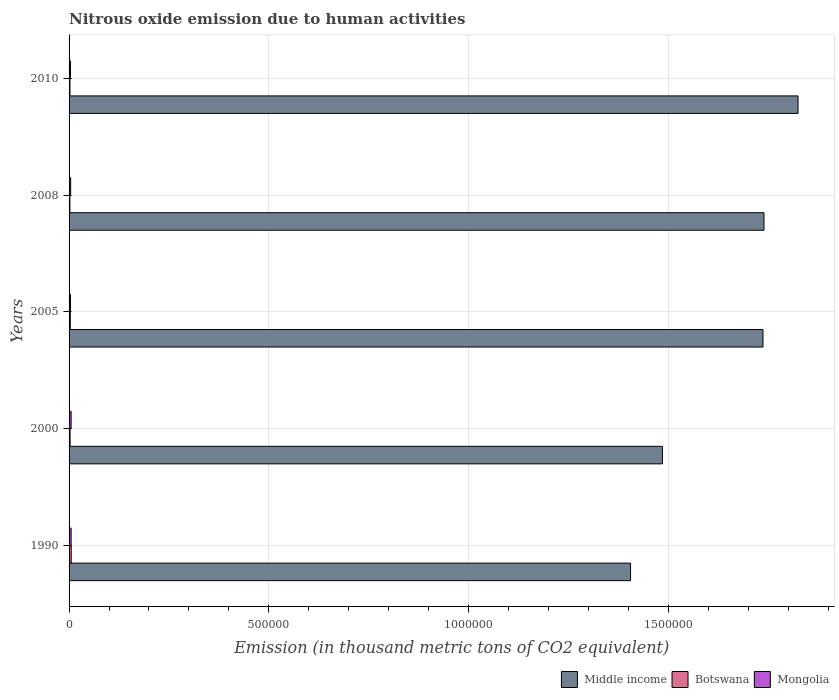How many groups of bars are there?
Your answer should be very brief. 5. Are the number of bars on each tick of the Y-axis equal?
Keep it short and to the point. Yes. In how many cases, is the number of bars for a given year not equal to the number of legend labels?
Ensure brevity in your answer.  0. What is the amount of nitrous oxide emitted in Middle income in 2010?
Your answer should be very brief. 1.82e+06. Across all years, what is the maximum amount of nitrous oxide emitted in Mongolia?
Provide a short and direct response. 5151. Across all years, what is the minimum amount of nitrous oxide emitted in Middle income?
Offer a terse response. 1.41e+06. In which year was the amount of nitrous oxide emitted in Middle income maximum?
Provide a succinct answer. 2010. In which year was the amount of nitrous oxide emitted in Mongolia minimum?
Keep it short and to the point. 2010. What is the total amount of nitrous oxide emitted in Botswana in the graph?
Keep it short and to the point. 1.52e+04. What is the difference between the amount of nitrous oxide emitted in Mongolia in 2000 and that in 2008?
Provide a short and direct response. 1153. What is the difference between the amount of nitrous oxide emitted in Botswana in 2010 and the amount of nitrous oxide emitted in Mongolia in 2005?
Your answer should be very brief. -1350.6. What is the average amount of nitrous oxide emitted in Middle income per year?
Offer a terse response. 1.64e+06. In the year 2000, what is the difference between the amount of nitrous oxide emitted in Middle income and amount of nitrous oxide emitted in Botswana?
Your answer should be compact. 1.48e+06. What is the ratio of the amount of nitrous oxide emitted in Mongolia in 2005 to that in 2010?
Ensure brevity in your answer.  1.02. Is the difference between the amount of nitrous oxide emitted in Middle income in 2008 and 2010 greater than the difference between the amount of nitrous oxide emitted in Botswana in 2008 and 2010?
Keep it short and to the point. No. What is the difference between the highest and the second highest amount of nitrous oxide emitted in Middle income?
Your answer should be very brief. 8.53e+04. What is the difference between the highest and the lowest amount of nitrous oxide emitted in Middle income?
Provide a short and direct response. 4.19e+05. Is the sum of the amount of nitrous oxide emitted in Middle income in 2005 and 2010 greater than the maximum amount of nitrous oxide emitted in Mongolia across all years?
Your answer should be compact. Yes. What does the 2nd bar from the top in 2005 represents?
Give a very brief answer. Botswana. What does the 3rd bar from the bottom in 2008 represents?
Provide a succinct answer. Mongolia. How many years are there in the graph?
Provide a short and direct response. 5. What is the difference between two consecutive major ticks on the X-axis?
Give a very brief answer. 5.00e+05. Does the graph contain any zero values?
Your response must be concise. No. Does the graph contain grids?
Provide a short and direct response. Yes. What is the title of the graph?
Ensure brevity in your answer.  Nitrous oxide emission due to human activities. Does "Gabon" appear as one of the legend labels in the graph?
Provide a short and direct response. No. What is the label or title of the X-axis?
Keep it short and to the point. Emission (in thousand metric tons of CO2 equivalent). What is the label or title of the Y-axis?
Offer a terse response. Years. What is the Emission (in thousand metric tons of CO2 equivalent) in Middle income in 1990?
Make the answer very short. 1.41e+06. What is the Emission (in thousand metric tons of CO2 equivalent) of Botswana in 1990?
Keep it short and to the point. 5394.5. What is the Emission (in thousand metric tons of CO2 equivalent) in Mongolia in 1990?
Make the answer very short. 5151. What is the Emission (in thousand metric tons of CO2 equivalent) of Middle income in 2000?
Provide a short and direct response. 1.49e+06. What is the Emission (in thousand metric tons of CO2 equivalent) of Botswana in 2000?
Offer a very short reply. 2523.6. What is the Emission (in thousand metric tons of CO2 equivalent) of Mongolia in 2000?
Ensure brevity in your answer.  5106.8. What is the Emission (in thousand metric tons of CO2 equivalent) of Middle income in 2005?
Your response must be concise. 1.74e+06. What is the Emission (in thousand metric tons of CO2 equivalent) in Botswana in 2005?
Keep it short and to the point. 3096.5. What is the Emission (in thousand metric tons of CO2 equivalent) in Mongolia in 2005?
Keep it short and to the point. 3535.4. What is the Emission (in thousand metric tons of CO2 equivalent) in Middle income in 2008?
Keep it short and to the point. 1.74e+06. What is the Emission (in thousand metric tons of CO2 equivalent) of Botswana in 2008?
Keep it short and to the point. 1998.1. What is the Emission (in thousand metric tons of CO2 equivalent) in Mongolia in 2008?
Provide a short and direct response. 3953.8. What is the Emission (in thousand metric tons of CO2 equivalent) of Middle income in 2010?
Keep it short and to the point. 1.82e+06. What is the Emission (in thousand metric tons of CO2 equivalent) of Botswana in 2010?
Make the answer very short. 2184.8. What is the Emission (in thousand metric tons of CO2 equivalent) in Mongolia in 2010?
Provide a succinct answer. 3478.2. Across all years, what is the maximum Emission (in thousand metric tons of CO2 equivalent) of Middle income?
Provide a short and direct response. 1.82e+06. Across all years, what is the maximum Emission (in thousand metric tons of CO2 equivalent) of Botswana?
Provide a short and direct response. 5394.5. Across all years, what is the maximum Emission (in thousand metric tons of CO2 equivalent) in Mongolia?
Your answer should be very brief. 5151. Across all years, what is the minimum Emission (in thousand metric tons of CO2 equivalent) of Middle income?
Your response must be concise. 1.41e+06. Across all years, what is the minimum Emission (in thousand metric tons of CO2 equivalent) in Botswana?
Make the answer very short. 1998.1. Across all years, what is the minimum Emission (in thousand metric tons of CO2 equivalent) of Mongolia?
Your answer should be compact. 3478.2. What is the total Emission (in thousand metric tons of CO2 equivalent) of Middle income in the graph?
Offer a terse response. 8.19e+06. What is the total Emission (in thousand metric tons of CO2 equivalent) of Botswana in the graph?
Your answer should be very brief. 1.52e+04. What is the total Emission (in thousand metric tons of CO2 equivalent) in Mongolia in the graph?
Provide a short and direct response. 2.12e+04. What is the difference between the Emission (in thousand metric tons of CO2 equivalent) in Middle income in 1990 and that in 2000?
Ensure brevity in your answer.  -7.98e+04. What is the difference between the Emission (in thousand metric tons of CO2 equivalent) of Botswana in 1990 and that in 2000?
Your answer should be compact. 2870.9. What is the difference between the Emission (in thousand metric tons of CO2 equivalent) in Mongolia in 1990 and that in 2000?
Give a very brief answer. 44.2. What is the difference between the Emission (in thousand metric tons of CO2 equivalent) in Middle income in 1990 and that in 2005?
Your response must be concise. -3.31e+05. What is the difference between the Emission (in thousand metric tons of CO2 equivalent) in Botswana in 1990 and that in 2005?
Your response must be concise. 2298. What is the difference between the Emission (in thousand metric tons of CO2 equivalent) in Mongolia in 1990 and that in 2005?
Offer a terse response. 1615.6. What is the difference between the Emission (in thousand metric tons of CO2 equivalent) of Middle income in 1990 and that in 2008?
Give a very brief answer. -3.34e+05. What is the difference between the Emission (in thousand metric tons of CO2 equivalent) in Botswana in 1990 and that in 2008?
Offer a terse response. 3396.4. What is the difference between the Emission (in thousand metric tons of CO2 equivalent) in Mongolia in 1990 and that in 2008?
Offer a very short reply. 1197.2. What is the difference between the Emission (in thousand metric tons of CO2 equivalent) of Middle income in 1990 and that in 2010?
Give a very brief answer. -4.19e+05. What is the difference between the Emission (in thousand metric tons of CO2 equivalent) of Botswana in 1990 and that in 2010?
Give a very brief answer. 3209.7. What is the difference between the Emission (in thousand metric tons of CO2 equivalent) in Mongolia in 1990 and that in 2010?
Make the answer very short. 1672.8. What is the difference between the Emission (in thousand metric tons of CO2 equivalent) of Middle income in 2000 and that in 2005?
Keep it short and to the point. -2.52e+05. What is the difference between the Emission (in thousand metric tons of CO2 equivalent) in Botswana in 2000 and that in 2005?
Your answer should be very brief. -572.9. What is the difference between the Emission (in thousand metric tons of CO2 equivalent) of Mongolia in 2000 and that in 2005?
Ensure brevity in your answer.  1571.4. What is the difference between the Emission (in thousand metric tons of CO2 equivalent) in Middle income in 2000 and that in 2008?
Your answer should be very brief. -2.54e+05. What is the difference between the Emission (in thousand metric tons of CO2 equivalent) of Botswana in 2000 and that in 2008?
Provide a short and direct response. 525.5. What is the difference between the Emission (in thousand metric tons of CO2 equivalent) in Mongolia in 2000 and that in 2008?
Make the answer very short. 1153. What is the difference between the Emission (in thousand metric tons of CO2 equivalent) in Middle income in 2000 and that in 2010?
Your answer should be very brief. -3.39e+05. What is the difference between the Emission (in thousand metric tons of CO2 equivalent) of Botswana in 2000 and that in 2010?
Keep it short and to the point. 338.8. What is the difference between the Emission (in thousand metric tons of CO2 equivalent) of Mongolia in 2000 and that in 2010?
Your answer should be compact. 1628.6. What is the difference between the Emission (in thousand metric tons of CO2 equivalent) in Middle income in 2005 and that in 2008?
Provide a succinct answer. -2525.2. What is the difference between the Emission (in thousand metric tons of CO2 equivalent) of Botswana in 2005 and that in 2008?
Give a very brief answer. 1098.4. What is the difference between the Emission (in thousand metric tons of CO2 equivalent) of Mongolia in 2005 and that in 2008?
Offer a very short reply. -418.4. What is the difference between the Emission (in thousand metric tons of CO2 equivalent) of Middle income in 2005 and that in 2010?
Ensure brevity in your answer.  -8.78e+04. What is the difference between the Emission (in thousand metric tons of CO2 equivalent) of Botswana in 2005 and that in 2010?
Give a very brief answer. 911.7. What is the difference between the Emission (in thousand metric tons of CO2 equivalent) in Mongolia in 2005 and that in 2010?
Your answer should be compact. 57.2. What is the difference between the Emission (in thousand metric tons of CO2 equivalent) of Middle income in 2008 and that in 2010?
Your answer should be compact. -8.53e+04. What is the difference between the Emission (in thousand metric tons of CO2 equivalent) of Botswana in 2008 and that in 2010?
Offer a terse response. -186.7. What is the difference between the Emission (in thousand metric tons of CO2 equivalent) in Mongolia in 2008 and that in 2010?
Make the answer very short. 475.6. What is the difference between the Emission (in thousand metric tons of CO2 equivalent) of Middle income in 1990 and the Emission (in thousand metric tons of CO2 equivalent) of Botswana in 2000?
Offer a terse response. 1.40e+06. What is the difference between the Emission (in thousand metric tons of CO2 equivalent) of Middle income in 1990 and the Emission (in thousand metric tons of CO2 equivalent) of Mongolia in 2000?
Offer a terse response. 1.40e+06. What is the difference between the Emission (in thousand metric tons of CO2 equivalent) in Botswana in 1990 and the Emission (in thousand metric tons of CO2 equivalent) in Mongolia in 2000?
Your response must be concise. 287.7. What is the difference between the Emission (in thousand metric tons of CO2 equivalent) in Middle income in 1990 and the Emission (in thousand metric tons of CO2 equivalent) in Botswana in 2005?
Offer a terse response. 1.40e+06. What is the difference between the Emission (in thousand metric tons of CO2 equivalent) in Middle income in 1990 and the Emission (in thousand metric tons of CO2 equivalent) in Mongolia in 2005?
Offer a very short reply. 1.40e+06. What is the difference between the Emission (in thousand metric tons of CO2 equivalent) in Botswana in 1990 and the Emission (in thousand metric tons of CO2 equivalent) in Mongolia in 2005?
Offer a terse response. 1859.1. What is the difference between the Emission (in thousand metric tons of CO2 equivalent) in Middle income in 1990 and the Emission (in thousand metric tons of CO2 equivalent) in Botswana in 2008?
Your answer should be compact. 1.40e+06. What is the difference between the Emission (in thousand metric tons of CO2 equivalent) of Middle income in 1990 and the Emission (in thousand metric tons of CO2 equivalent) of Mongolia in 2008?
Ensure brevity in your answer.  1.40e+06. What is the difference between the Emission (in thousand metric tons of CO2 equivalent) of Botswana in 1990 and the Emission (in thousand metric tons of CO2 equivalent) of Mongolia in 2008?
Make the answer very short. 1440.7. What is the difference between the Emission (in thousand metric tons of CO2 equivalent) of Middle income in 1990 and the Emission (in thousand metric tons of CO2 equivalent) of Botswana in 2010?
Your answer should be very brief. 1.40e+06. What is the difference between the Emission (in thousand metric tons of CO2 equivalent) in Middle income in 1990 and the Emission (in thousand metric tons of CO2 equivalent) in Mongolia in 2010?
Your answer should be very brief. 1.40e+06. What is the difference between the Emission (in thousand metric tons of CO2 equivalent) of Botswana in 1990 and the Emission (in thousand metric tons of CO2 equivalent) of Mongolia in 2010?
Provide a succinct answer. 1916.3. What is the difference between the Emission (in thousand metric tons of CO2 equivalent) in Middle income in 2000 and the Emission (in thousand metric tons of CO2 equivalent) in Botswana in 2005?
Offer a very short reply. 1.48e+06. What is the difference between the Emission (in thousand metric tons of CO2 equivalent) in Middle income in 2000 and the Emission (in thousand metric tons of CO2 equivalent) in Mongolia in 2005?
Offer a terse response. 1.48e+06. What is the difference between the Emission (in thousand metric tons of CO2 equivalent) of Botswana in 2000 and the Emission (in thousand metric tons of CO2 equivalent) of Mongolia in 2005?
Your response must be concise. -1011.8. What is the difference between the Emission (in thousand metric tons of CO2 equivalent) of Middle income in 2000 and the Emission (in thousand metric tons of CO2 equivalent) of Botswana in 2008?
Provide a short and direct response. 1.48e+06. What is the difference between the Emission (in thousand metric tons of CO2 equivalent) of Middle income in 2000 and the Emission (in thousand metric tons of CO2 equivalent) of Mongolia in 2008?
Offer a very short reply. 1.48e+06. What is the difference between the Emission (in thousand metric tons of CO2 equivalent) of Botswana in 2000 and the Emission (in thousand metric tons of CO2 equivalent) of Mongolia in 2008?
Your response must be concise. -1430.2. What is the difference between the Emission (in thousand metric tons of CO2 equivalent) of Middle income in 2000 and the Emission (in thousand metric tons of CO2 equivalent) of Botswana in 2010?
Offer a terse response. 1.48e+06. What is the difference between the Emission (in thousand metric tons of CO2 equivalent) of Middle income in 2000 and the Emission (in thousand metric tons of CO2 equivalent) of Mongolia in 2010?
Offer a terse response. 1.48e+06. What is the difference between the Emission (in thousand metric tons of CO2 equivalent) in Botswana in 2000 and the Emission (in thousand metric tons of CO2 equivalent) in Mongolia in 2010?
Offer a terse response. -954.6. What is the difference between the Emission (in thousand metric tons of CO2 equivalent) in Middle income in 2005 and the Emission (in thousand metric tons of CO2 equivalent) in Botswana in 2008?
Provide a succinct answer. 1.73e+06. What is the difference between the Emission (in thousand metric tons of CO2 equivalent) of Middle income in 2005 and the Emission (in thousand metric tons of CO2 equivalent) of Mongolia in 2008?
Your answer should be very brief. 1.73e+06. What is the difference between the Emission (in thousand metric tons of CO2 equivalent) of Botswana in 2005 and the Emission (in thousand metric tons of CO2 equivalent) of Mongolia in 2008?
Provide a short and direct response. -857.3. What is the difference between the Emission (in thousand metric tons of CO2 equivalent) in Middle income in 2005 and the Emission (in thousand metric tons of CO2 equivalent) in Botswana in 2010?
Give a very brief answer. 1.73e+06. What is the difference between the Emission (in thousand metric tons of CO2 equivalent) in Middle income in 2005 and the Emission (in thousand metric tons of CO2 equivalent) in Mongolia in 2010?
Provide a succinct answer. 1.73e+06. What is the difference between the Emission (in thousand metric tons of CO2 equivalent) of Botswana in 2005 and the Emission (in thousand metric tons of CO2 equivalent) of Mongolia in 2010?
Make the answer very short. -381.7. What is the difference between the Emission (in thousand metric tons of CO2 equivalent) in Middle income in 2008 and the Emission (in thousand metric tons of CO2 equivalent) in Botswana in 2010?
Make the answer very short. 1.74e+06. What is the difference between the Emission (in thousand metric tons of CO2 equivalent) in Middle income in 2008 and the Emission (in thousand metric tons of CO2 equivalent) in Mongolia in 2010?
Make the answer very short. 1.74e+06. What is the difference between the Emission (in thousand metric tons of CO2 equivalent) in Botswana in 2008 and the Emission (in thousand metric tons of CO2 equivalent) in Mongolia in 2010?
Provide a short and direct response. -1480.1. What is the average Emission (in thousand metric tons of CO2 equivalent) in Middle income per year?
Provide a succinct answer. 1.64e+06. What is the average Emission (in thousand metric tons of CO2 equivalent) in Botswana per year?
Provide a succinct answer. 3039.5. What is the average Emission (in thousand metric tons of CO2 equivalent) in Mongolia per year?
Give a very brief answer. 4245.04. In the year 1990, what is the difference between the Emission (in thousand metric tons of CO2 equivalent) of Middle income and Emission (in thousand metric tons of CO2 equivalent) of Botswana?
Make the answer very short. 1.40e+06. In the year 1990, what is the difference between the Emission (in thousand metric tons of CO2 equivalent) of Middle income and Emission (in thousand metric tons of CO2 equivalent) of Mongolia?
Your response must be concise. 1.40e+06. In the year 1990, what is the difference between the Emission (in thousand metric tons of CO2 equivalent) in Botswana and Emission (in thousand metric tons of CO2 equivalent) in Mongolia?
Offer a terse response. 243.5. In the year 2000, what is the difference between the Emission (in thousand metric tons of CO2 equivalent) in Middle income and Emission (in thousand metric tons of CO2 equivalent) in Botswana?
Give a very brief answer. 1.48e+06. In the year 2000, what is the difference between the Emission (in thousand metric tons of CO2 equivalent) of Middle income and Emission (in thousand metric tons of CO2 equivalent) of Mongolia?
Offer a very short reply. 1.48e+06. In the year 2000, what is the difference between the Emission (in thousand metric tons of CO2 equivalent) in Botswana and Emission (in thousand metric tons of CO2 equivalent) in Mongolia?
Offer a very short reply. -2583.2. In the year 2005, what is the difference between the Emission (in thousand metric tons of CO2 equivalent) in Middle income and Emission (in thousand metric tons of CO2 equivalent) in Botswana?
Your response must be concise. 1.73e+06. In the year 2005, what is the difference between the Emission (in thousand metric tons of CO2 equivalent) in Middle income and Emission (in thousand metric tons of CO2 equivalent) in Mongolia?
Your answer should be very brief. 1.73e+06. In the year 2005, what is the difference between the Emission (in thousand metric tons of CO2 equivalent) in Botswana and Emission (in thousand metric tons of CO2 equivalent) in Mongolia?
Your response must be concise. -438.9. In the year 2008, what is the difference between the Emission (in thousand metric tons of CO2 equivalent) in Middle income and Emission (in thousand metric tons of CO2 equivalent) in Botswana?
Provide a succinct answer. 1.74e+06. In the year 2008, what is the difference between the Emission (in thousand metric tons of CO2 equivalent) of Middle income and Emission (in thousand metric tons of CO2 equivalent) of Mongolia?
Your answer should be very brief. 1.74e+06. In the year 2008, what is the difference between the Emission (in thousand metric tons of CO2 equivalent) of Botswana and Emission (in thousand metric tons of CO2 equivalent) of Mongolia?
Your response must be concise. -1955.7. In the year 2010, what is the difference between the Emission (in thousand metric tons of CO2 equivalent) of Middle income and Emission (in thousand metric tons of CO2 equivalent) of Botswana?
Your answer should be very brief. 1.82e+06. In the year 2010, what is the difference between the Emission (in thousand metric tons of CO2 equivalent) in Middle income and Emission (in thousand metric tons of CO2 equivalent) in Mongolia?
Your response must be concise. 1.82e+06. In the year 2010, what is the difference between the Emission (in thousand metric tons of CO2 equivalent) in Botswana and Emission (in thousand metric tons of CO2 equivalent) in Mongolia?
Give a very brief answer. -1293.4. What is the ratio of the Emission (in thousand metric tons of CO2 equivalent) in Middle income in 1990 to that in 2000?
Provide a succinct answer. 0.95. What is the ratio of the Emission (in thousand metric tons of CO2 equivalent) in Botswana in 1990 to that in 2000?
Provide a short and direct response. 2.14. What is the ratio of the Emission (in thousand metric tons of CO2 equivalent) of Mongolia in 1990 to that in 2000?
Make the answer very short. 1.01. What is the ratio of the Emission (in thousand metric tons of CO2 equivalent) in Middle income in 1990 to that in 2005?
Offer a very short reply. 0.81. What is the ratio of the Emission (in thousand metric tons of CO2 equivalent) of Botswana in 1990 to that in 2005?
Provide a short and direct response. 1.74. What is the ratio of the Emission (in thousand metric tons of CO2 equivalent) of Mongolia in 1990 to that in 2005?
Ensure brevity in your answer.  1.46. What is the ratio of the Emission (in thousand metric tons of CO2 equivalent) in Middle income in 1990 to that in 2008?
Your answer should be compact. 0.81. What is the ratio of the Emission (in thousand metric tons of CO2 equivalent) in Botswana in 1990 to that in 2008?
Your response must be concise. 2.7. What is the ratio of the Emission (in thousand metric tons of CO2 equivalent) in Mongolia in 1990 to that in 2008?
Offer a very short reply. 1.3. What is the ratio of the Emission (in thousand metric tons of CO2 equivalent) in Middle income in 1990 to that in 2010?
Keep it short and to the point. 0.77. What is the ratio of the Emission (in thousand metric tons of CO2 equivalent) in Botswana in 1990 to that in 2010?
Give a very brief answer. 2.47. What is the ratio of the Emission (in thousand metric tons of CO2 equivalent) of Mongolia in 1990 to that in 2010?
Offer a terse response. 1.48. What is the ratio of the Emission (in thousand metric tons of CO2 equivalent) of Middle income in 2000 to that in 2005?
Provide a succinct answer. 0.86. What is the ratio of the Emission (in thousand metric tons of CO2 equivalent) in Botswana in 2000 to that in 2005?
Your answer should be compact. 0.81. What is the ratio of the Emission (in thousand metric tons of CO2 equivalent) of Mongolia in 2000 to that in 2005?
Your answer should be very brief. 1.44. What is the ratio of the Emission (in thousand metric tons of CO2 equivalent) in Middle income in 2000 to that in 2008?
Provide a succinct answer. 0.85. What is the ratio of the Emission (in thousand metric tons of CO2 equivalent) in Botswana in 2000 to that in 2008?
Offer a very short reply. 1.26. What is the ratio of the Emission (in thousand metric tons of CO2 equivalent) in Mongolia in 2000 to that in 2008?
Your answer should be very brief. 1.29. What is the ratio of the Emission (in thousand metric tons of CO2 equivalent) of Middle income in 2000 to that in 2010?
Ensure brevity in your answer.  0.81. What is the ratio of the Emission (in thousand metric tons of CO2 equivalent) in Botswana in 2000 to that in 2010?
Offer a very short reply. 1.16. What is the ratio of the Emission (in thousand metric tons of CO2 equivalent) in Mongolia in 2000 to that in 2010?
Provide a succinct answer. 1.47. What is the ratio of the Emission (in thousand metric tons of CO2 equivalent) of Middle income in 2005 to that in 2008?
Give a very brief answer. 1. What is the ratio of the Emission (in thousand metric tons of CO2 equivalent) in Botswana in 2005 to that in 2008?
Provide a short and direct response. 1.55. What is the ratio of the Emission (in thousand metric tons of CO2 equivalent) in Mongolia in 2005 to that in 2008?
Keep it short and to the point. 0.89. What is the ratio of the Emission (in thousand metric tons of CO2 equivalent) of Middle income in 2005 to that in 2010?
Provide a short and direct response. 0.95. What is the ratio of the Emission (in thousand metric tons of CO2 equivalent) in Botswana in 2005 to that in 2010?
Your response must be concise. 1.42. What is the ratio of the Emission (in thousand metric tons of CO2 equivalent) in Mongolia in 2005 to that in 2010?
Offer a very short reply. 1.02. What is the ratio of the Emission (in thousand metric tons of CO2 equivalent) in Middle income in 2008 to that in 2010?
Provide a succinct answer. 0.95. What is the ratio of the Emission (in thousand metric tons of CO2 equivalent) in Botswana in 2008 to that in 2010?
Provide a succinct answer. 0.91. What is the ratio of the Emission (in thousand metric tons of CO2 equivalent) in Mongolia in 2008 to that in 2010?
Provide a succinct answer. 1.14. What is the difference between the highest and the second highest Emission (in thousand metric tons of CO2 equivalent) of Middle income?
Your answer should be very brief. 8.53e+04. What is the difference between the highest and the second highest Emission (in thousand metric tons of CO2 equivalent) of Botswana?
Your answer should be very brief. 2298. What is the difference between the highest and the second highest Emission (in thousand metric tons of CO2 equivalent) in Mongolia?
Your response must be concise. 44.2. What is the difference between the highest and the lowest Emission (in thousand metric tons of CO2 equivalent) of Middle income?
Give a very brief answer. 4.19e+05. What is the difference between the highest and the lowest Emission (in thousand metric tons of CO2 equivalent) of Botswana?
Provide a short and direct response. 3396.4. What is the difference between the highest and the lowest Emission (in thousand metric tons of CO2 equivalent) of Mongolia?
Provide a short and direct response. 1672.8. 